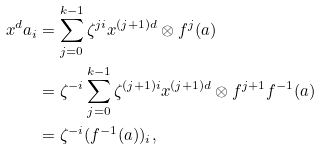<formula> <loc_0><loc_0><loc_500><loc_500>x ^ { d } a _ { i } & = \sum _ { j = 0 } ^ { k - 1 } \zeta ^ { j i } x ^ { ( j + 1 ) d } \otimes f ^ { j } ( a ) \\ & = \zeta ^ { - i } \sum _ { j = 0 } ^ { k - 1 } \zeta ^ { ( j + 1 ) i } x ^ { ( j + 1 ) d } \otimes f ^ { j + 1 } f ^ { - 1 } ( a ) \\ & = \zeta ^ { - i } ( f ^ { - 1 } ( a ) ) _ { i } ,</formula> 